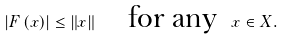<formula> <loc_0><loc_0><loc_500><loc_500>\left | F \left ( x \right ) \right | \leq \left \| x \right \| \quad \text {for any \ } x \in X .</formula> 